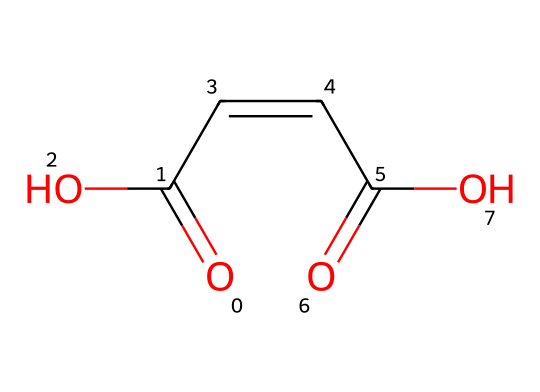What is the chemical name of this compound? The SMILES notation corresponds to a compound with two carboxylic acid groups and a double bond, which identifies it as maleic acid.
Answer: maleic acid How many carbon atoms are present in the structure? By analyzing the SMILES representation, we can identify four carbon atoms in total, as indicated by the 'C' symbols before and after the double bond.
Answer: four What type of isomerism is exhibited by maleic acid? This compound can exhibit geometric isomerism due to the presence of a double bond with different groups attached to the carbons, specifically cis and trans configurations.
Answer: geometric isomerism What functional groups are present in maleic acid? The chemical structure shows two carboxylic acid groups (-COOH), which are the functional groups in this compound.
Answer: carboxylic acids What is the total number of hydrogen atoms in maleic acid? In the structure, each carbon forms a full complement of bonds, leading to a total of four hydrogen atoms attached, based on valence rules.
Answer: four Which type of geometric isomerization can maleic acid undergo? Given its structure, maleic acid can undergo cis-trans isomerization due to its rigid double bond, where the positions of the carboxylic groups can vary.
Answer: cis-trans isomerization What indicates the reactivity of maleic acid in preservation treatments? The presence of the two carboxylic acid groups suggests high reactivity, as these groups can participate in various chemical reactions, such as esterification or polymerization.
Answer: high reactivity 